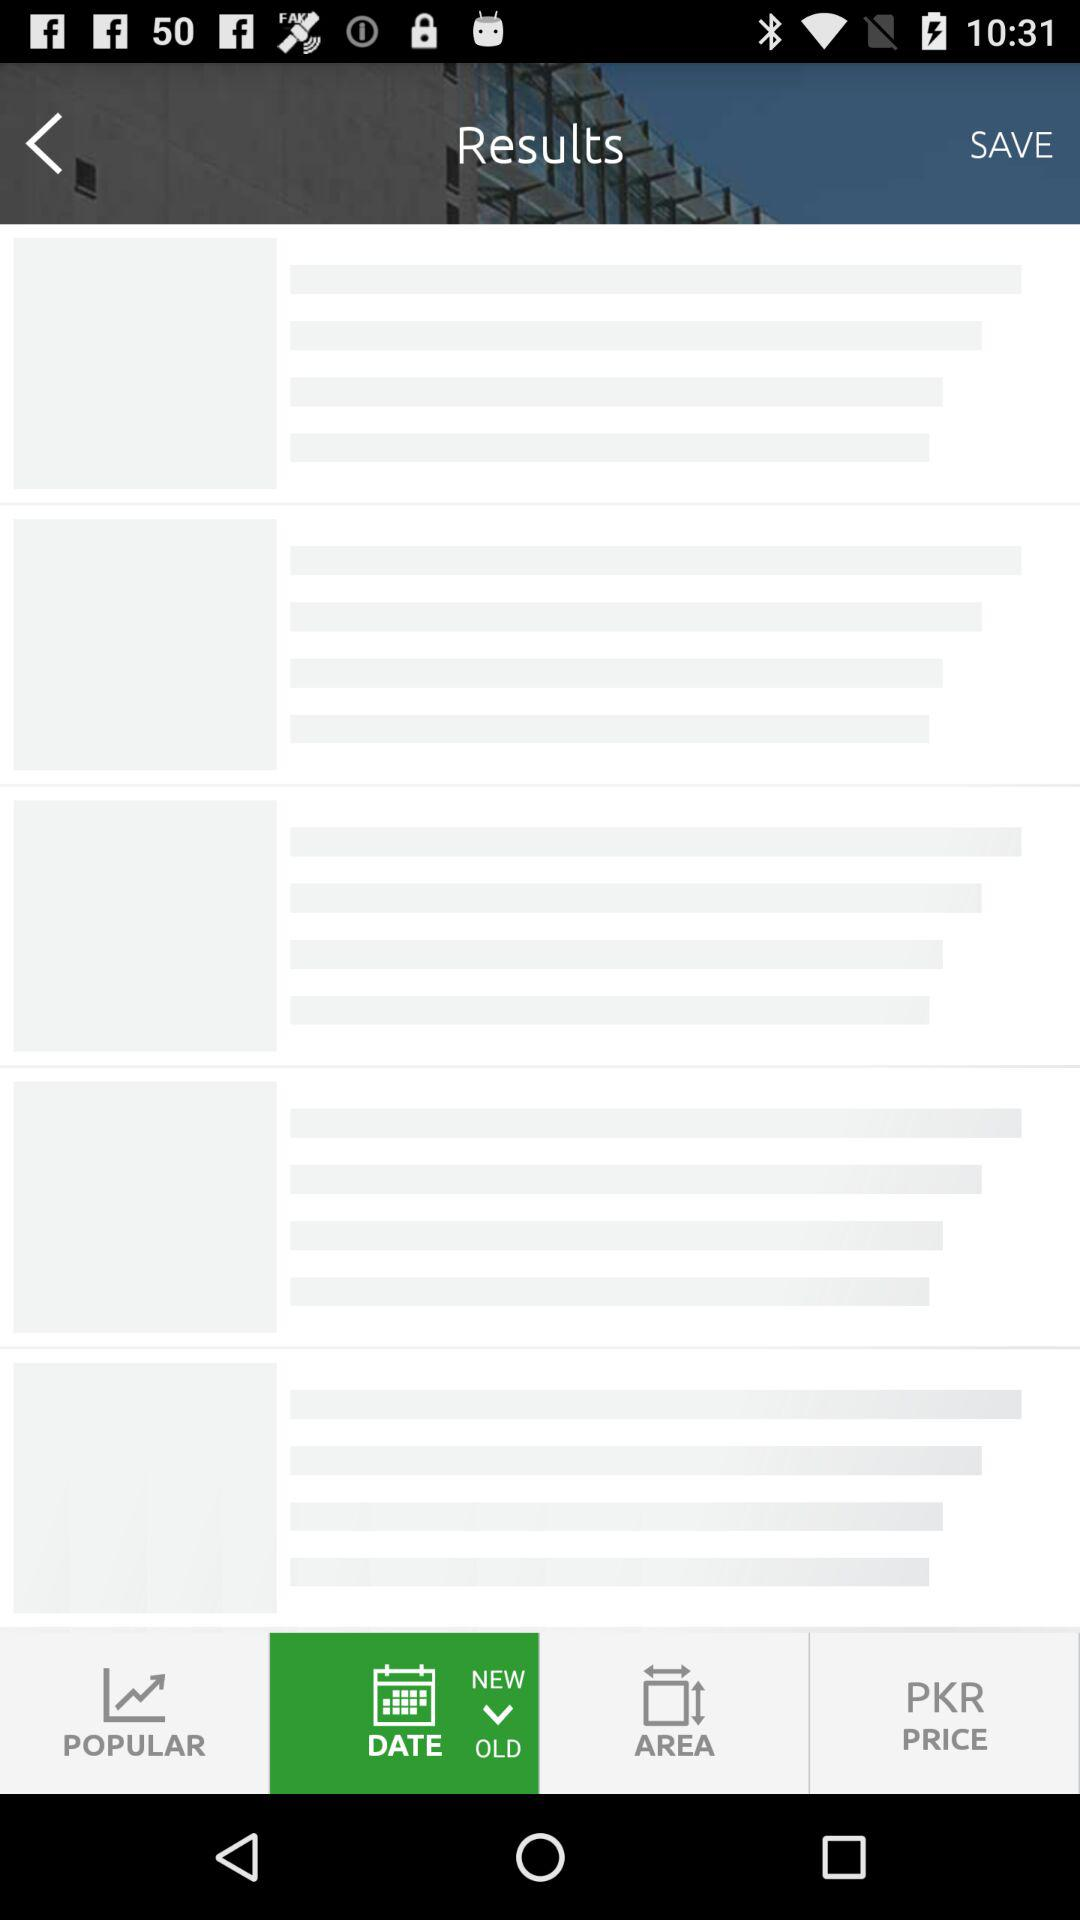Where is the property located? The property is located in DHA Phase 6-Block G, DHA Phase 6, DHA Defence. 